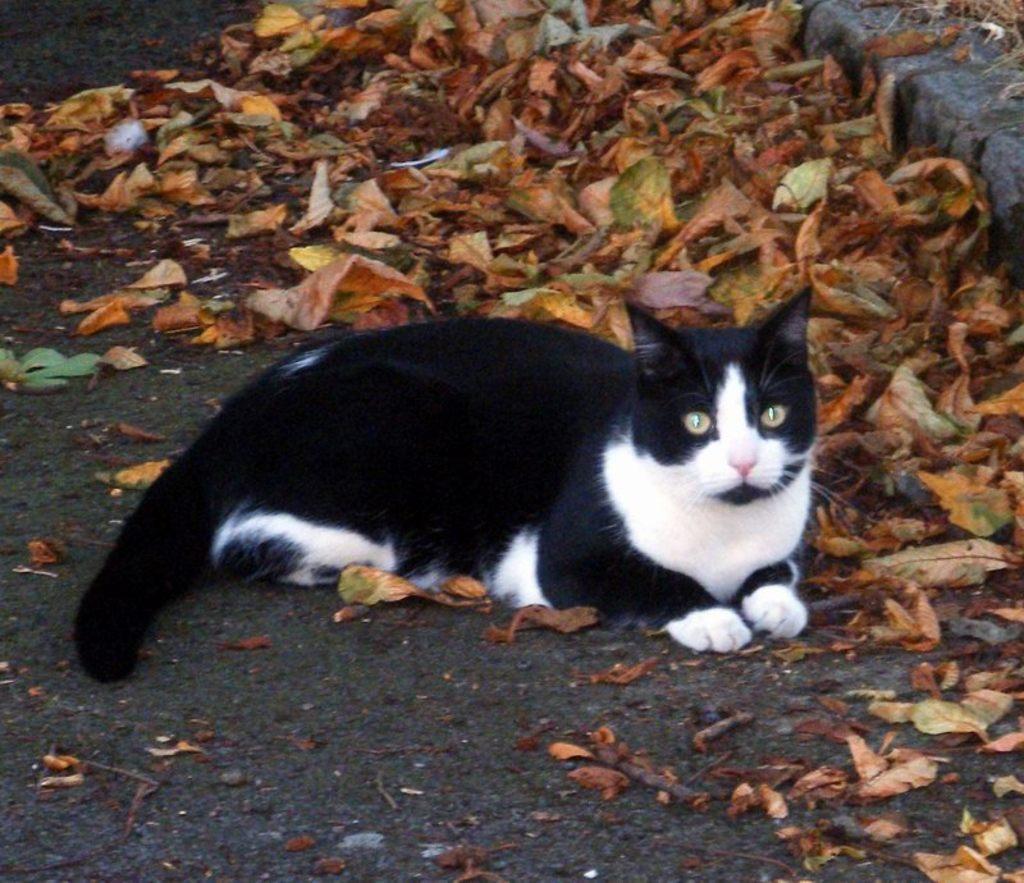Please provide a concise description of this image. In this picture, there is a cat sitting on the ground. It is in black and white in color. On the top, there are dried leaves. 